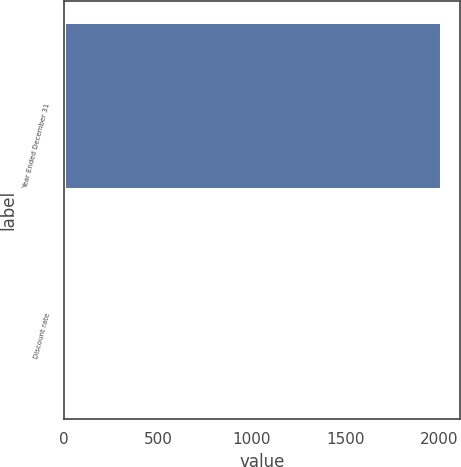Convert chart to OTSL. <chart><loc_0><loc_0><loc_500><loc_500><bar_chart><fcel>Year Ended December 31<fcel>Discount rate<nl><fcel>2012<fcel>4.5<nl></chart> 